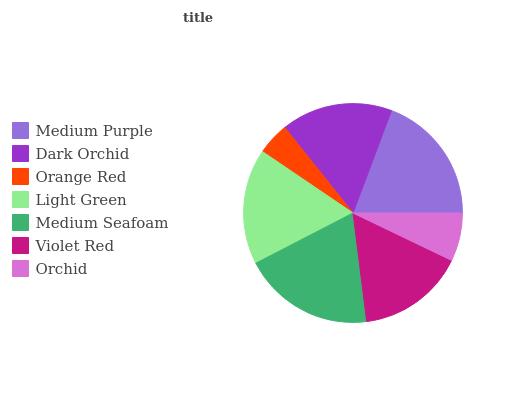Is Orange Red the minimum?
Answer yes or no. Yes. Is Medium Seafoam the maximum?
Answer yes or no. Yes. Is Dark Orchid the minimum?
Answer yes or no. No. Is Dark Orchid the maximum?
Answer yes or no. No. Is Medium Purple greater than Dark Orchid?
Answer yes or no. Yes. Is Dark Orchid less than Medium Purple?
Answer yes or no. Yes. Is Dark Orchid greater than Medium Purple?
Answer yes or no. No. Is Medium Purple less than Dark Orchid?
Answer yes or no. No. Is Dark Orchid the high median?
Answer yes or no. Yes. Is Dark Orchid the low median?
Answer yes or no. Yes. Is Medium Seafoam the high median?
Answer yes or no. No. Is Orchid the low median?
Answer yes or no. No. 